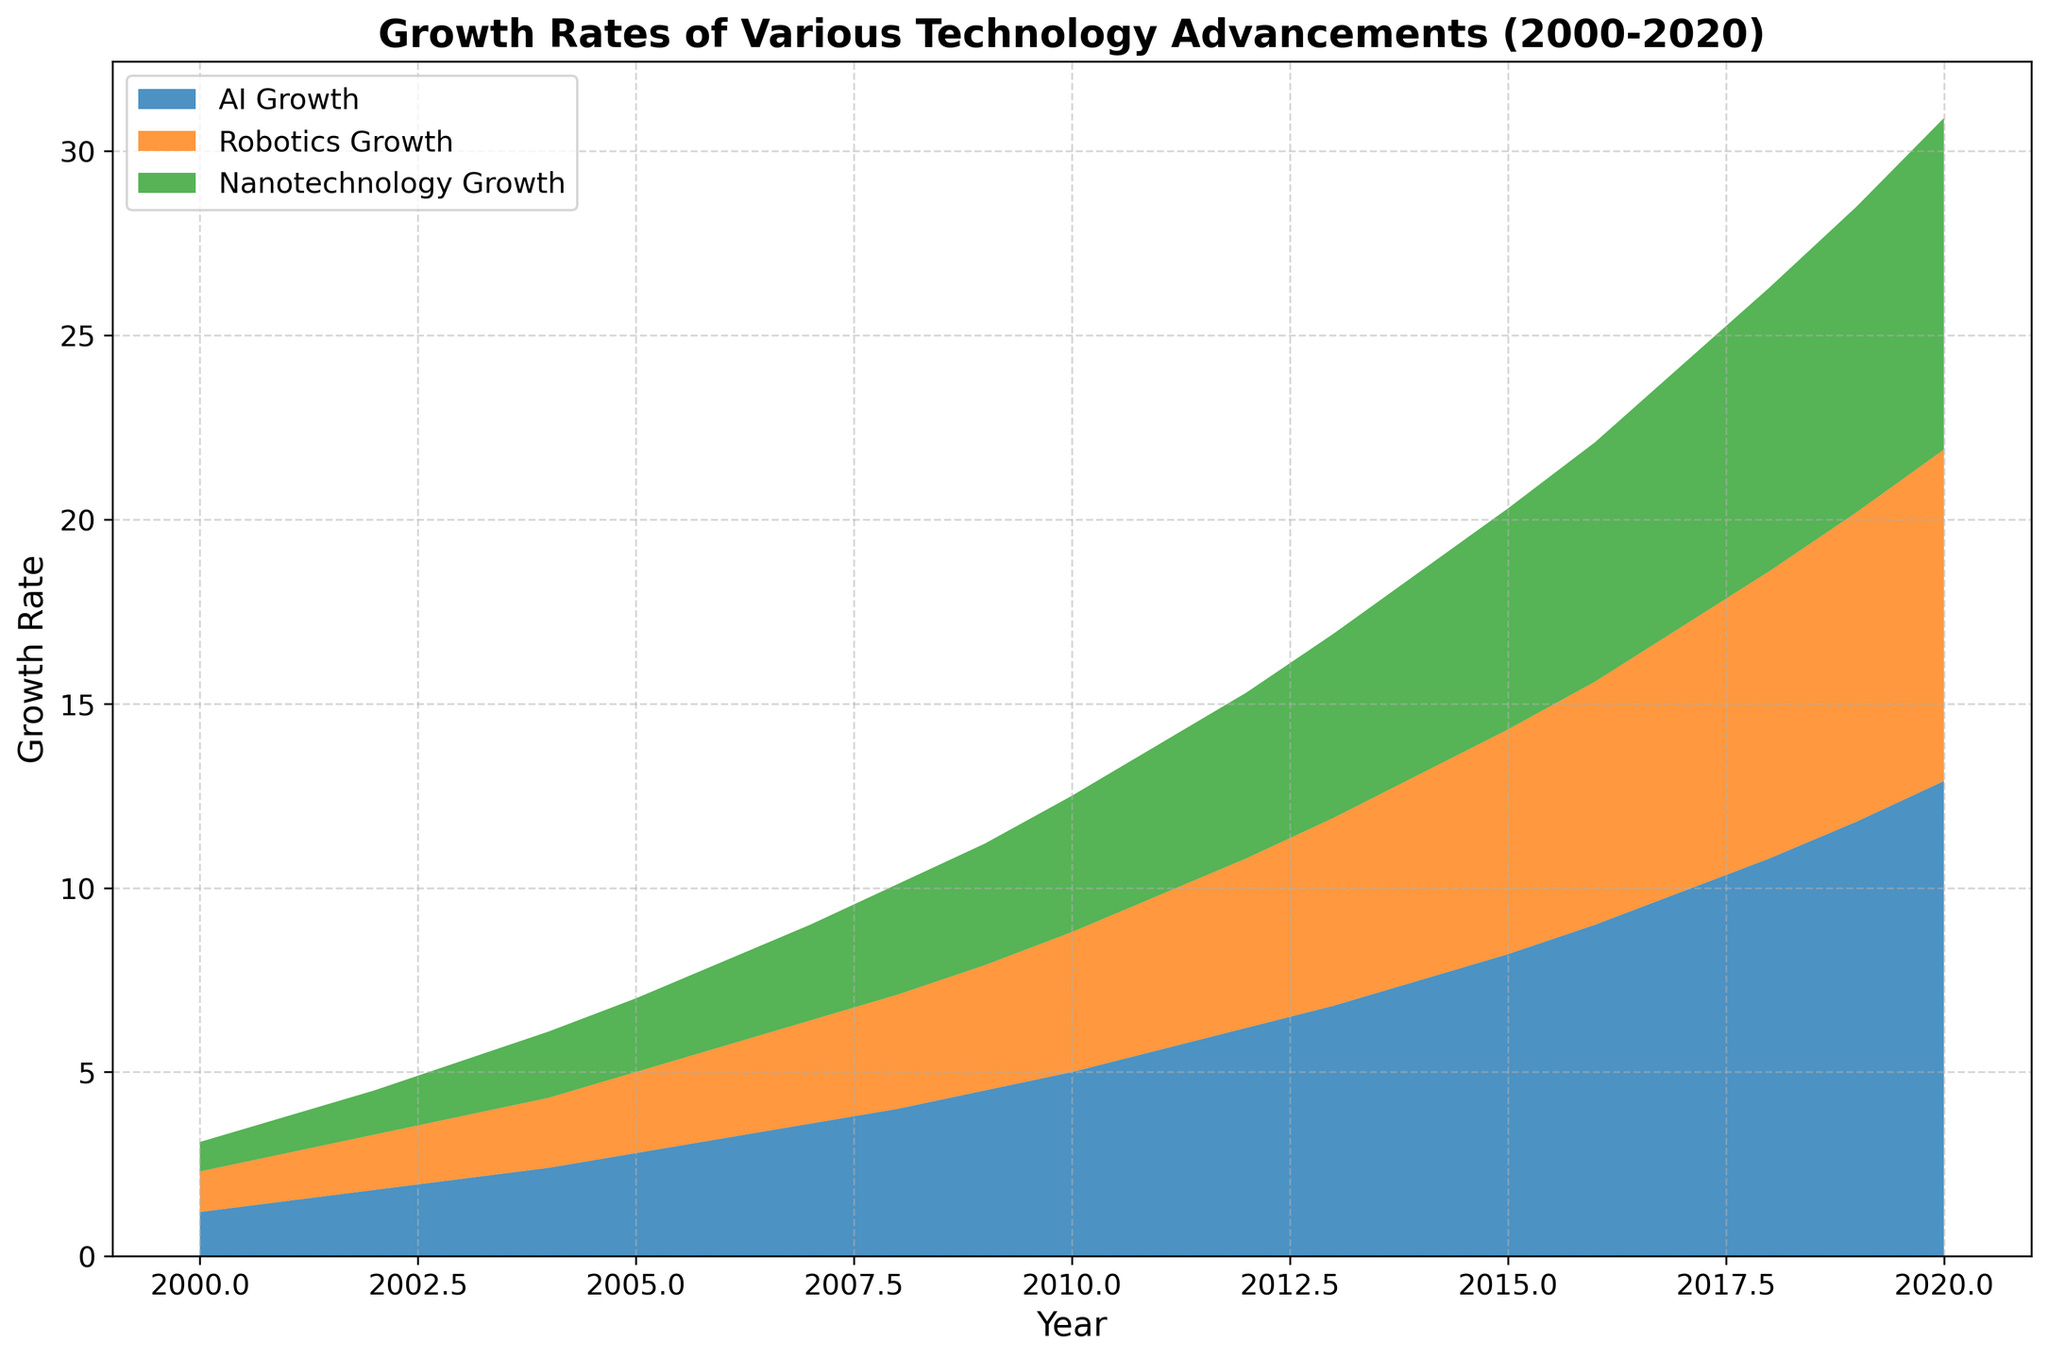What is the overall trend of AI growth from 2000 to 2020? The trend of AI growth can be seen visually increasing each year from 2000 to 2020. Starting from approximately 1.2 in 2000 and reaching around 12.9 by 2020, indicating steady and significant growth.
Answer: Steady increase Which technology had the slowest growth rate by the year 2010? By visually comparing the heights of the areas up to the year 2010, nanotechnology has the lowest growth rate at approximately 3.7, AI at 5.0, and robotics at 3.8, making nanotechnology the slowest.
Answer: Nanotechnology Comparing AI and robotics, which had a higher growth rate in 2008, and by how much? In 2008, the AI growth rate was 4.0, and the robotics growth rate was 3.1. By subtracting these values, the difference is 0.9.
Answer: AI by 0.9 What is the visual difference in growth rates between robotics and nanotechnology in 2020? In 2020, the visual differences show robotics at 9.0 and nanotechnology also at 9.0, indicating no visual difference.
Answer: No difference Summing the growth rates of AI, robotics, and nanotechnology in 2015, what is the total? Summing the values for 2015: AI growth rate (8.2) + robotics growth rate (6.1) + nanotechnology growth rate (6.0) = 20.3
Answer: 20.3 From the graph, which technology surpasses a growth rate of 10 first, and in which year? By examining the growth curves, AI surpasses the growth rate of 10 first in 2018 with an AI growth rate of 10.8.
Answer: AI in 2018 How does the growth rate of nanotechnology in 2020 compare to its growth rate in 2005? The growth rate for nanotechnology in 2005 is 2.0, and in 2020 it is 9.0. Subtracting these, there's an increase of 7.0 over these 15 years.
Answer: Increased by 7.0 By the year 2012, how much has AI growth increased compared to its growth in 2002? AI growth rate in 2002 is 1.8 and in 2012 is 6.2. The difference is 6.2 - 1.8 = 4.4.
Answer: Increased by 4.4 Comparing the growth rates, which technology advances most consistently from 2000 to 2020, and how can you tell? AI consistently shows uniform growth and a continuous upward trajectory compared to the others. Its growth does not have any significant dips or plateaus, indicating steady increase throughout.
Answer: AI What is the average growth rate of robotics from 2000 to 2010? Sum the growth rates of robotics from 2000 to 2010: 1.1 + 1.3 + 1.5 + 1.7 + 1.9 + 2.2 + 2.5 + 2.8 + 3.1 + 3.4 + 3.8 = 25.3. There are 11 years from 2000 to 2010. Average = 25.3 / 11 ≈ 2.3
Answer: 2.3 